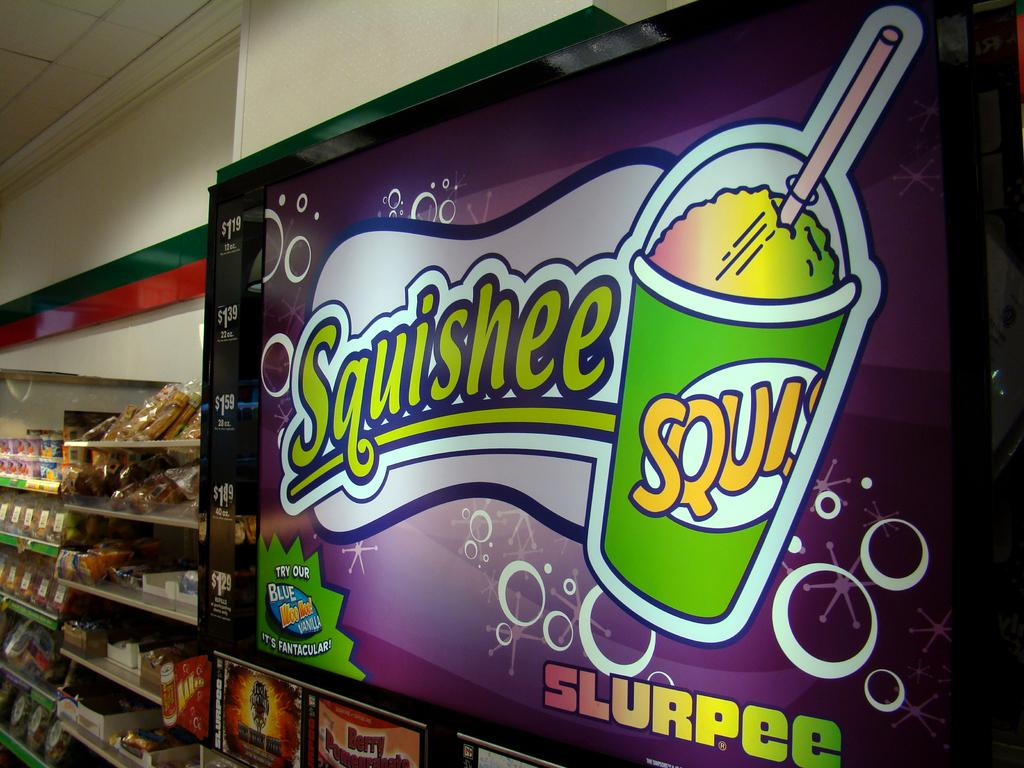<image>
Offer a succinct explanation of the picture presented. the inside of a gas station with a sign that says 'squishee slurpee' 